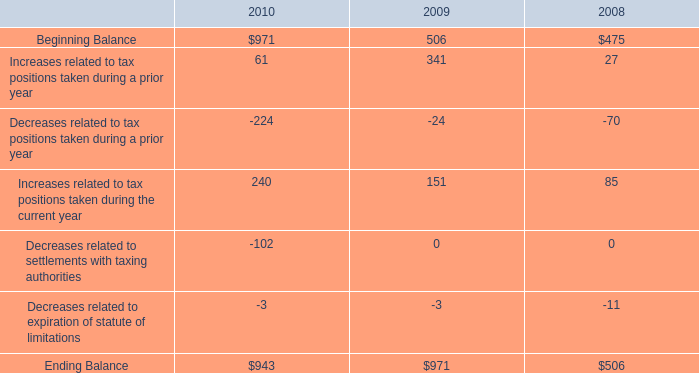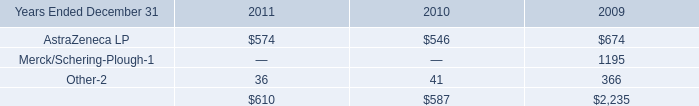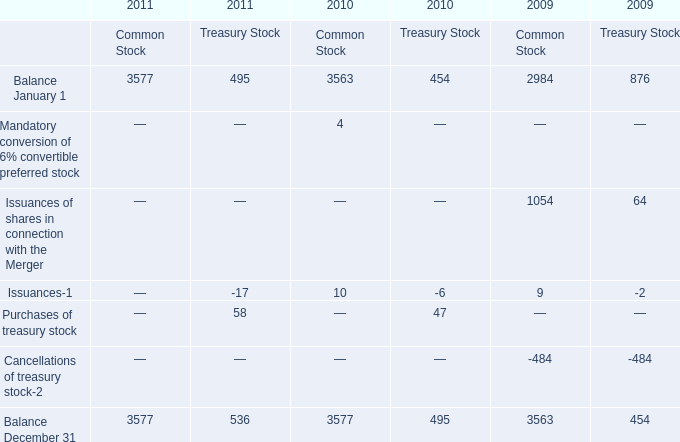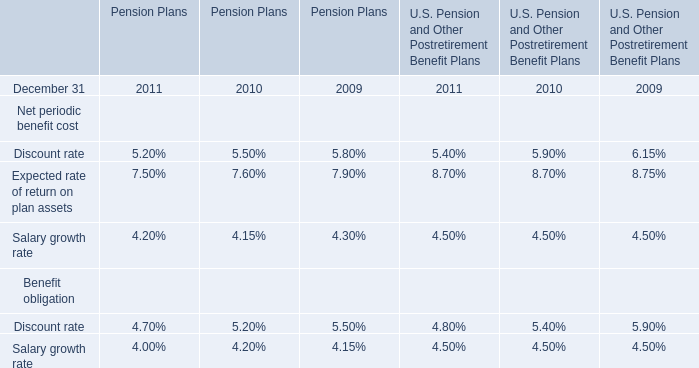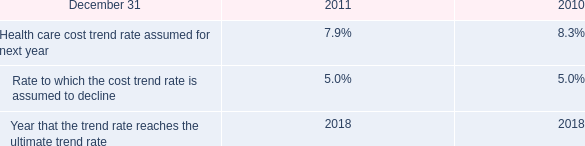Which year is Issuances of shares in connection with the Merger for Common Stock greater than 1000 ? 
Answer: 2009. 